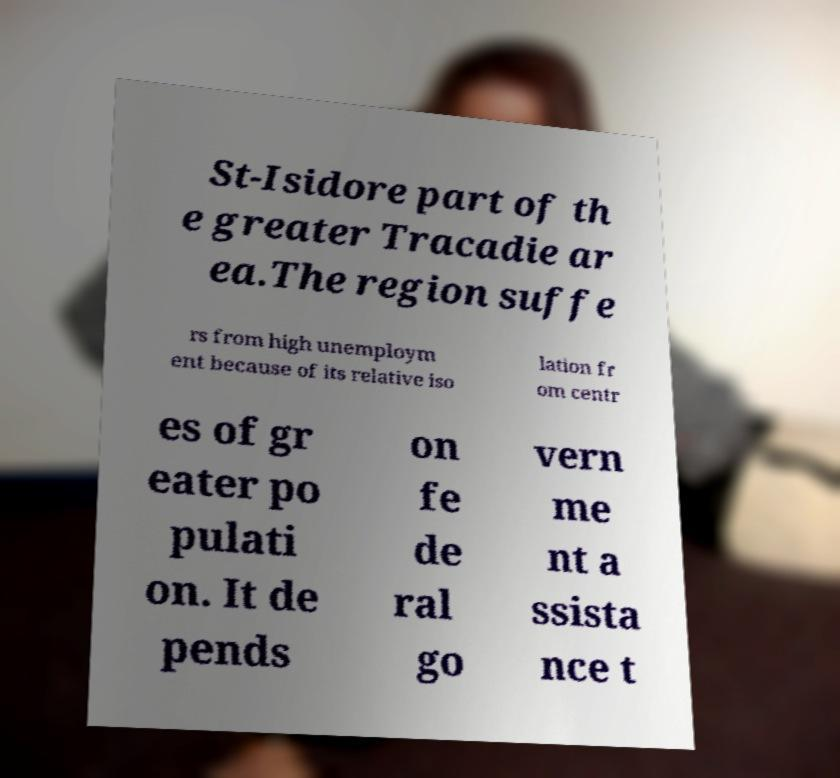Can you accurately transcribe the text from the provided image for me? St-Isidore part of th e greater Tracadie ar ea.The region suffe rs from high unemploym ent because of its relative iso lation fr om centr es of gr eater po pulati on. It de pends on fe de ral go vern me nt a ssista nce t 